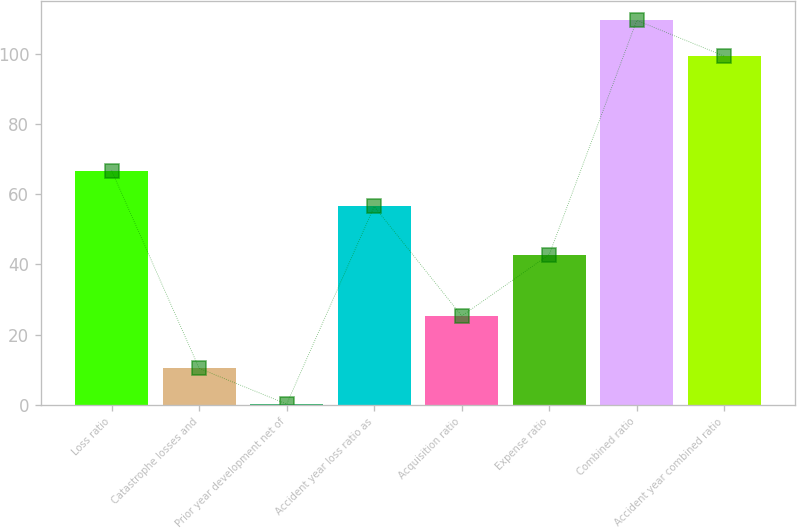Convert chart. <chart><loc_0><loc_0><loc_500><loc_500><bar_chart><fcel>Loss ratio<fcel>Catastrophe losses and<fcel>Prior year development net of<fcel>Accident year loss ratio as<fcel>Acquisition ratio<fcel>Expense ratio<fcel>Combined ratio<fcel>Accident year combined ratio<nl><fcel>66.69<fcel>10.39<fcel>0.2<fcel>56.5<fcel>25.3<fcel>42.8<fcel>109.49<fcel>99.3<nl></chart> 